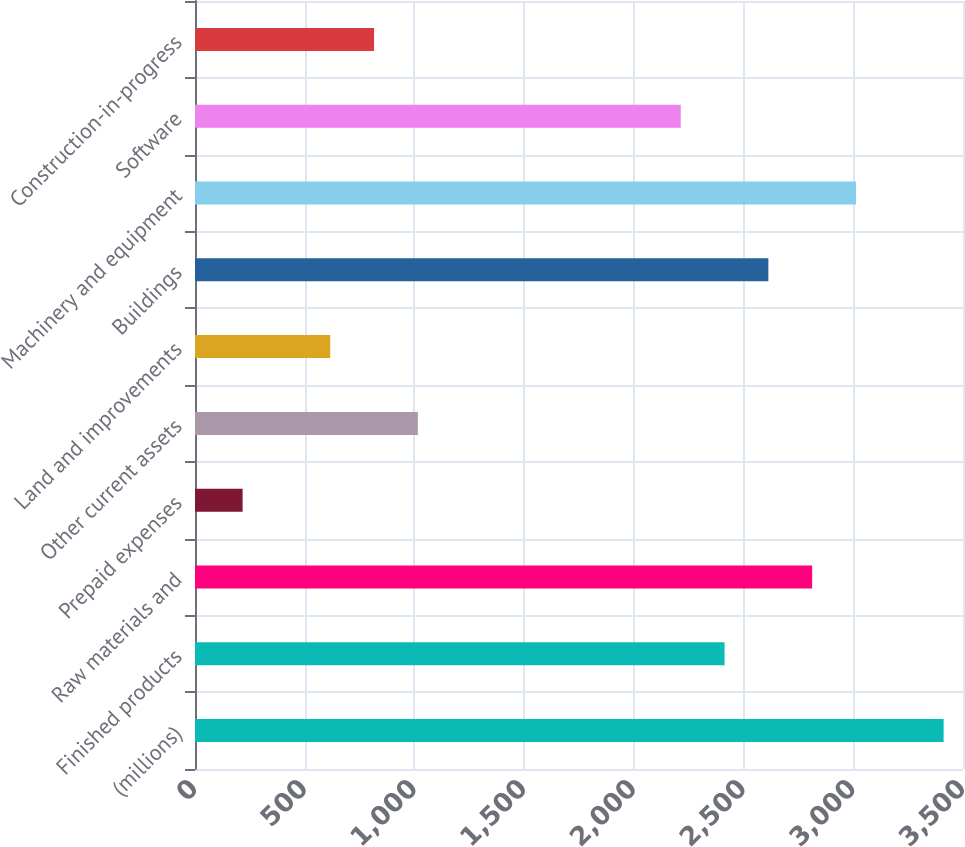<chart> <loc_0><loc_0><loc_500><loc_500><bar_chart><fcel>(millions)<fcel>Finished products<fcel>Raw materials and<fcel>Prepaid expenses<fcel>Other current assets<fcel>Land and improvements<fcel>Buildings<fcel>Machinery and equipment<fcel>Software<fcel>Construction-in-progress<nl><fcel>3411.69<fcel>2413.34<fcel>2812.68<fcel>216.97<fcel>1015.65<fcel>616.31<fcel>2613.01<fcel>3012.35<fcel>2213.67<fcel>815.98<nl></chart> 